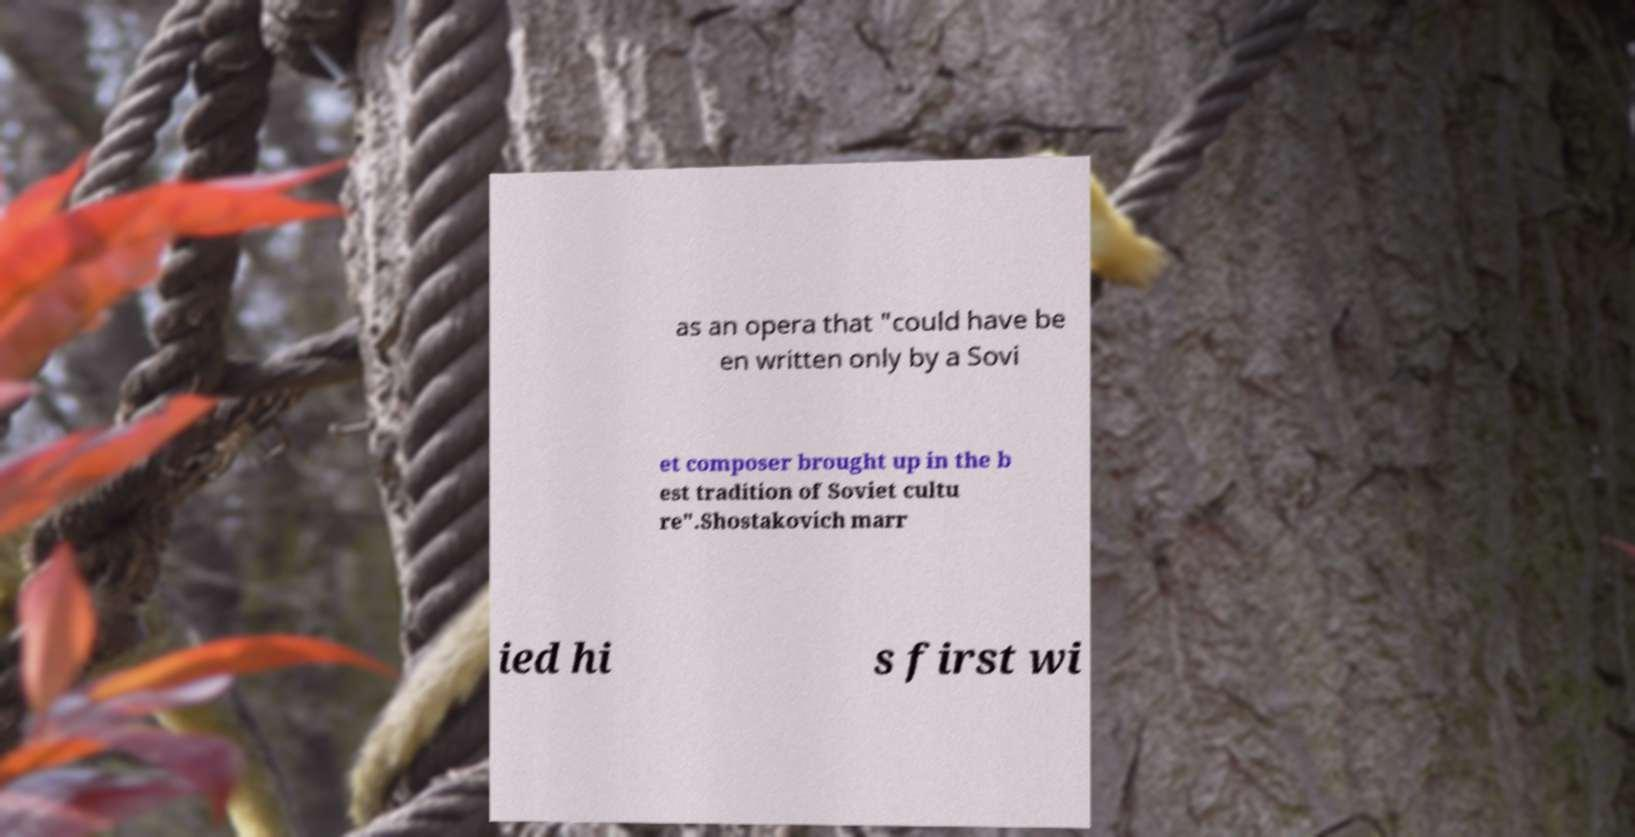Can you accurately transcribe the text from the provided image for me? as an opera that "could have be en written only by a Sovi et composer brought up in the b est tradition of Soviet cultu re".Shostakovich marr ied hi s first wi 